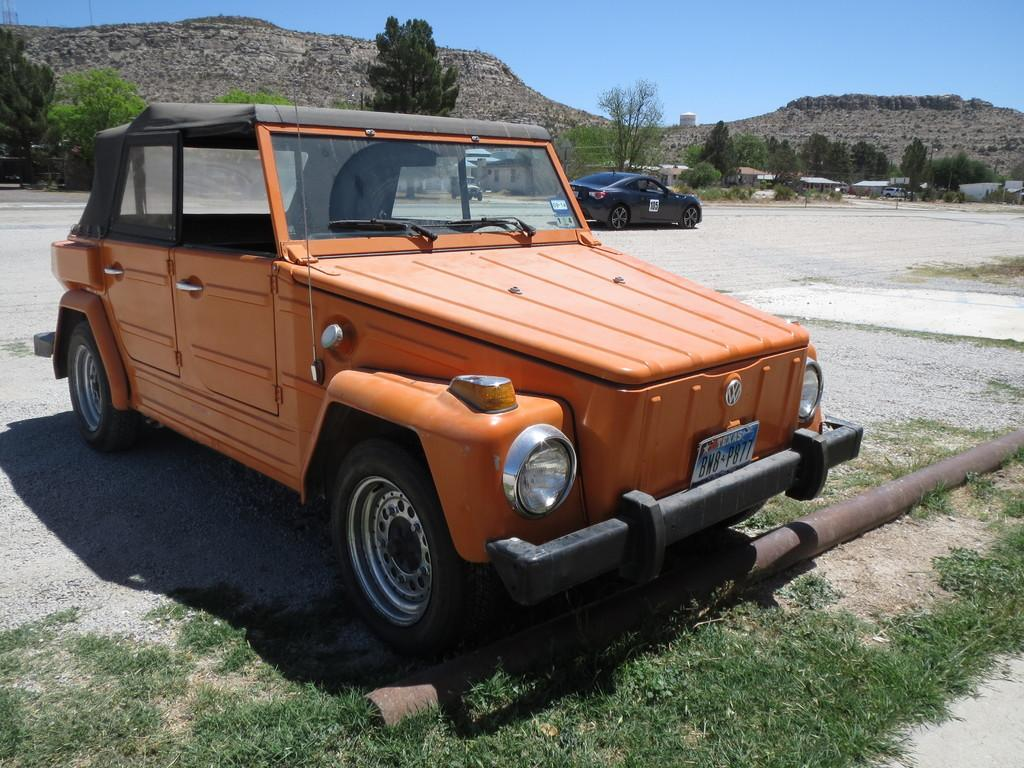What types of man-made structures are present in the image? There are vehicles and buildings in the image. What natural elements can be seen in the image? There are trees and hills in the image. What is visible in the background of the image? The sky is visible in the background of the image. How many clocks can be seen hanging on the trees in the image? There are no clocks hanging on the trees in the image. What type of ball is being played with in the image? There is no ball present in the image. 